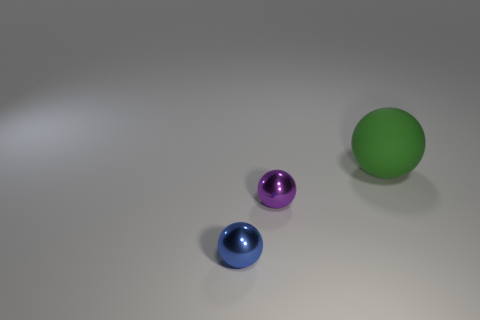Is there any other thing that is made of the same material as the large sphere?
Offer a very short reply. No. There is a tiny purple metallic thing; is its shape the same as the tiny metal object in front of the purple ball?
Your response must be concise. Yes. What number of spheres are either brown things or small purple things?
Keep it short and to the point. 1. What is the shape of the metal thing that is to the left of the tiny purple shiny object?
Keep it short and to the point. Sphere. What number of other large green things have the same material as the green thing?
Your answer should be compact. 0. Is the number of big green rubber balls that are behind the green matte thing less than the number of green cylinders?
Give a very brief answer. No. There is a ball that is in front of the shiny thing that is behind the blue thing; what is its size?
Provide a succinct answer. Small. What material is the purple object that is the same size as the blue metal sphere?
Offer a terse response. Metal. Is the number of small objects on the left side of the big matte thing less than the number of small shiny spheres behind the small blue metallic sphere?
Your answer should be compact. No. Are there any brown shiny cylinders?
Give a very brief answer. No. 